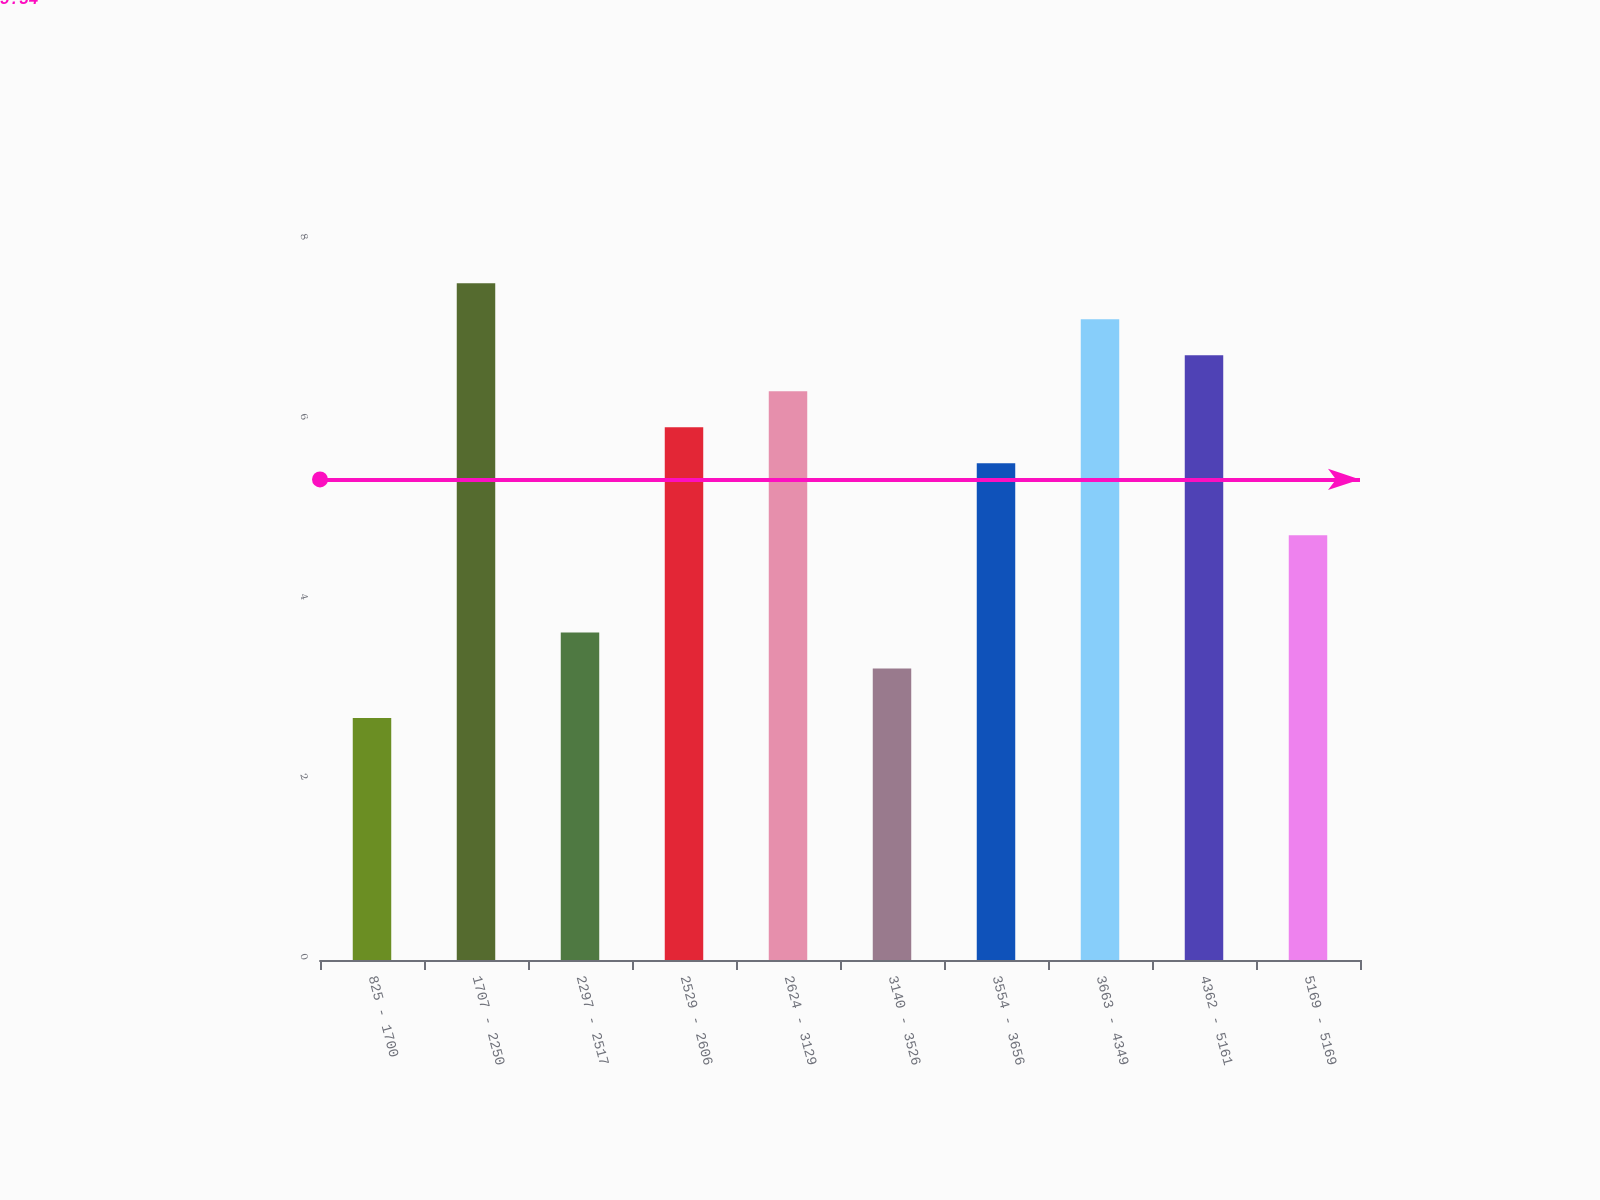Convert chart to OTSL. <chart><loc_0><loc_0><loc_500><loc_500><bar_chart><fcel>825 - 1700<fcel>1707 - 2250<fcel>2297 - 2517<fcel>2529 - 2606<fcel>2624 - 3129<fcel>3140 - 3526<fcel>3554 - 3656<fcel>3663 - 4349<fcel>4362 - 5161<fcel>5169 - 5169<nl><fcel>2.69<fcel>7.52<fcel>3.64<fcel>5.92<fcel>6.32<fcel>3.24<fcel>5.52<fcel>7.12<fcel>6.72<fcel>4.72<nl></chart> 